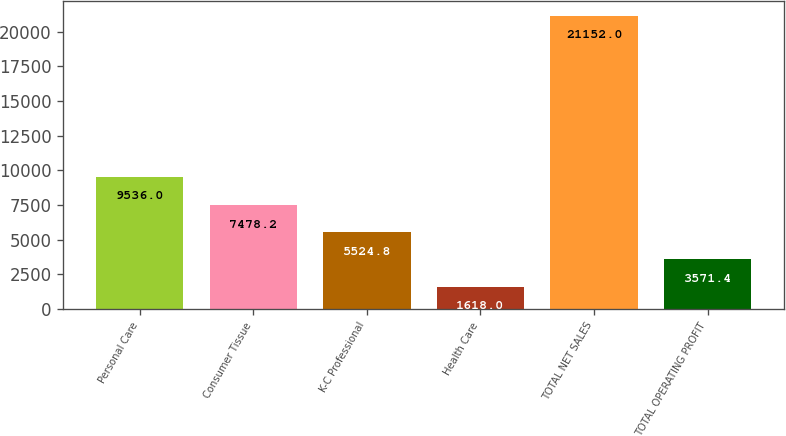Convert chart to OTSL. <chart><loc_0><loc_0><loc_500><loc_500><bar_chart><fcel>Personal Care<fcel>Consumer Tissue<fcel>K-C Professional<fcel>Health Care<fcel>TOTAL NET SALES<fcel>TOTAL OPERATING PROFIT<nl><fcel>9536<fcel>7478.2<fcel>5524.8<fcel>1618<fcel>21152<fcel>3571.4<nl></chart> 